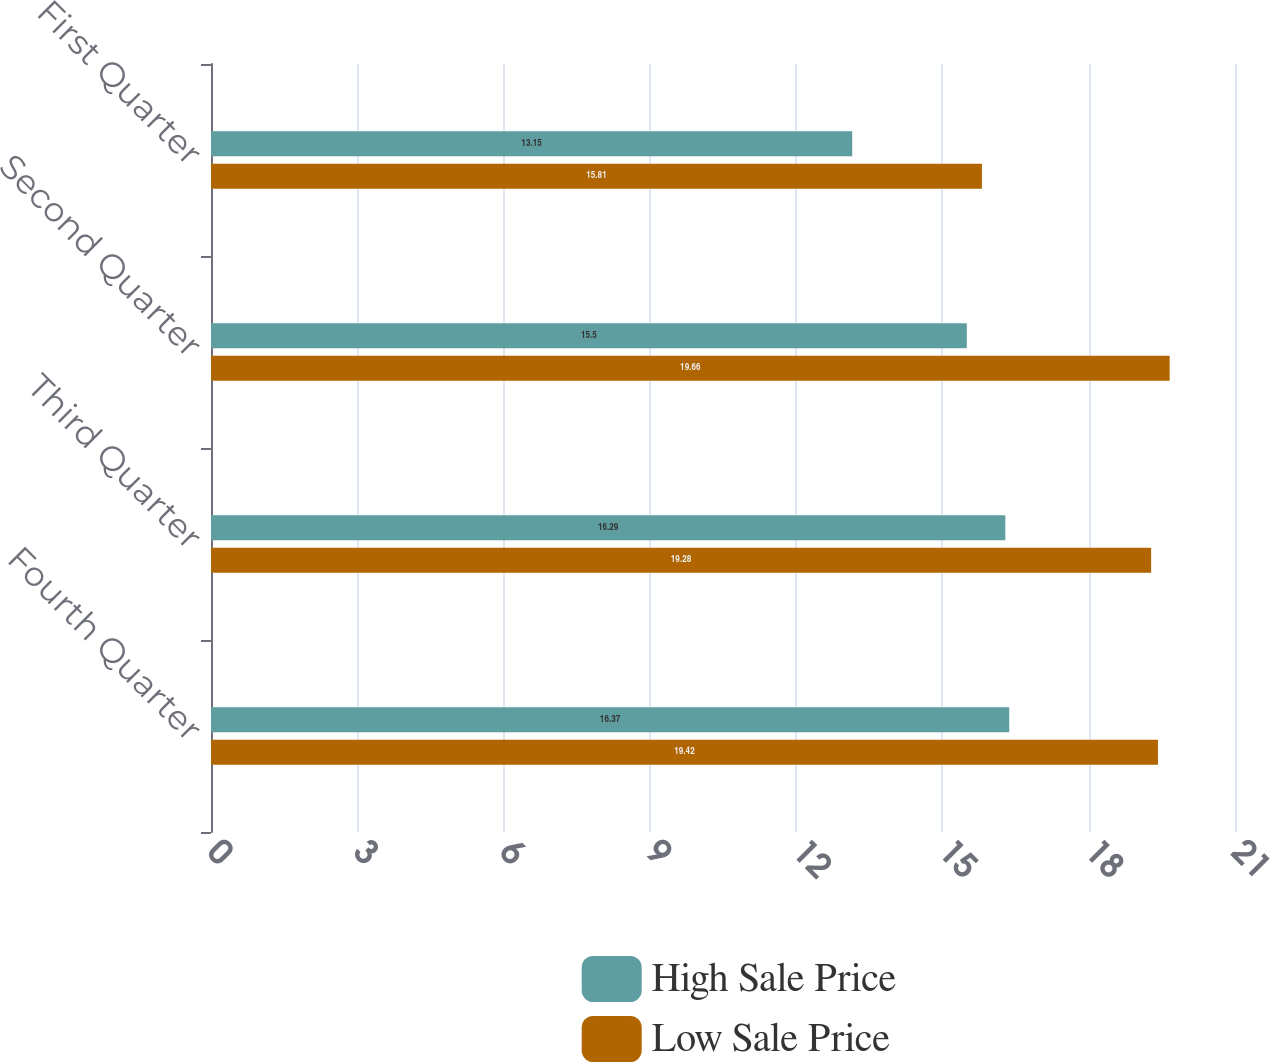<chart> <loc_0><loc_0><loc_500><loc_500><stacked_bar_chart><ecel><fcel>Fourth Quarter<fcel>Third Quarter<fcel>Second Quarter<fcel>First Quarter<nl><fcel>High Sale Price<fcel>16.37<fcel>16.29<fcel>15.5<fcel>13.15<nl><fcel>Low Sale Price<fcel>19.42<fcel>19.28<fcel>19.66<fcel>15.81<nl></chart> 